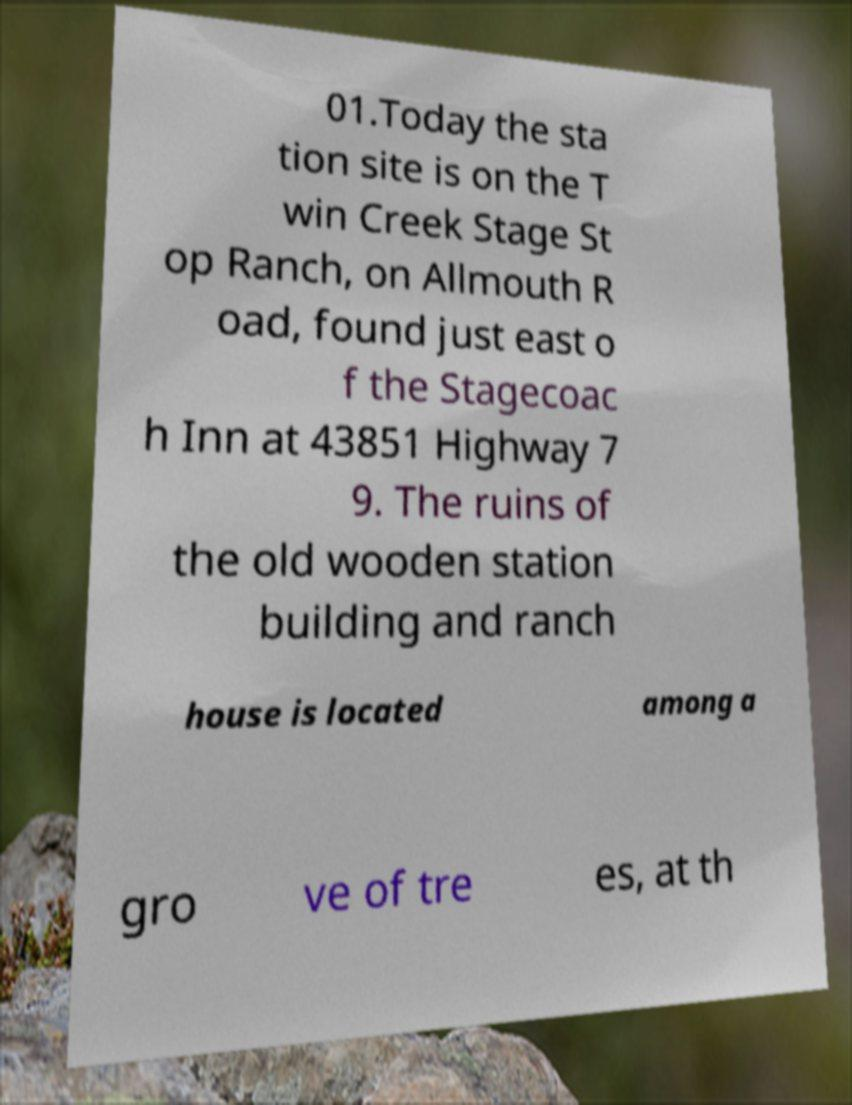Could you extract and type out the text from this image? 01.Today the sta tion site is on the T win Creek Stage St op Ranch, on Allmouth R oad, found just east o f the Stagecoac h Inn at 43851 Highway 7 9. The ruins of the old wooden station building and ranch house is located among a gro ve of tre es, at th 